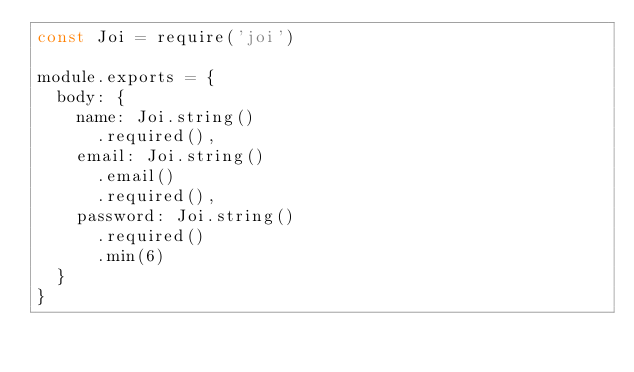<code> <loc_0><loc_0><loc_500><loc_500><_JavaScript_>const Joi = require('joi')

module.exports = {
  body: {
    name: Joi.string()
      .required(),
    email: Joi.string()
      .email()
      .required(),
    password: Joi.string()
      .required()
      .min(6)
  }
}
</code> 